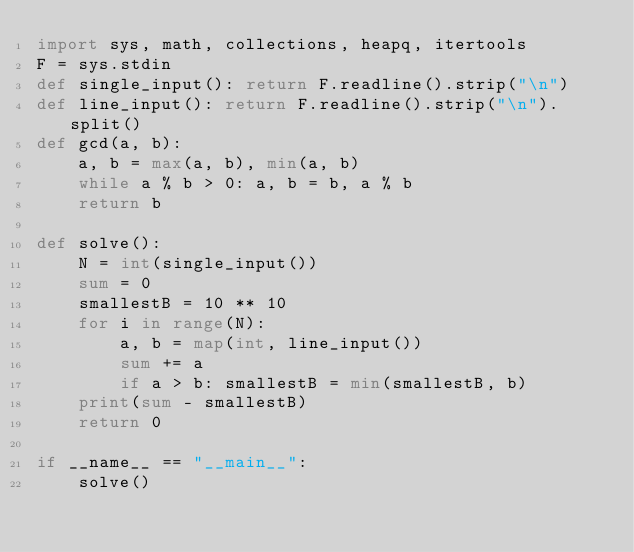<code> <loc_0><loc_0><loc_500><loc_500><_Python_>import sys, math, collections, heapq, itertools
F = sys.stdin
def single_input(): return F.readline().strip("\n")
def line_input(): return F.readline().strip("\n").split()
def gcd(a, b):
    a, b = max(a, b), min(a, b)
    while a % b > 0: a, b = b, a % b
    return b
  
def solve():
    N = int(single_input())
    sum = 0
    smallestB = 10 ** 10
    for i in range(N):
        a, b = map(int, line_input())
        sum += a
        if a > b: smallestB = min(smallestB, b)
    print(sum - smallestB)
    return 0
  
if __name__ == "__main__":
    solve()</code> 